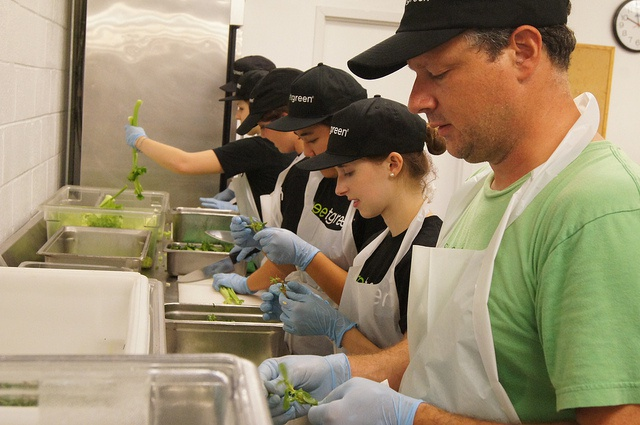Describe the objects in this image and their specific colors. I can see people in lightgray, olive, darkgray, brown, and black tones, refrigerator in lightgray, tan, and beige tones, people in lightgray, black, gray, and brown tones, people in lightgray, black, darkgray, gray, and maroon tones, and people in lightgray, black, tan, and gray tones in this image. 